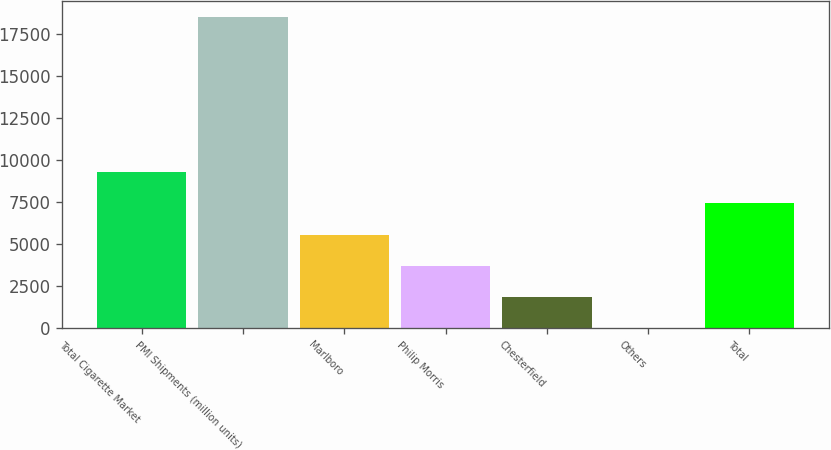Convert chart to OTSL. <chart><loc_0><loc_0><loc_500><loc_500><bar_chart><fcel>Total Cigarette Market<fcel>PMI Shipments (million units)<fcel>Marlboro<fcel>Philip Morris<fcel>Chesterfield<fcel>Others<fcel>Total<nl><fcel>9283.05<fcel>18563<fcel>5571.07<fcel>3715.08<fcel>1859.09<fcel>3.1<fcel>7427.06<nl></chart> 